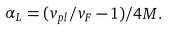Convert formula to latex. <formula><loc_0><loc_0><loc_500><loc_500>\alpha _ { L } = ( v _ { p l } / v _ { F } - 1 ) / 4 M .</formula> 